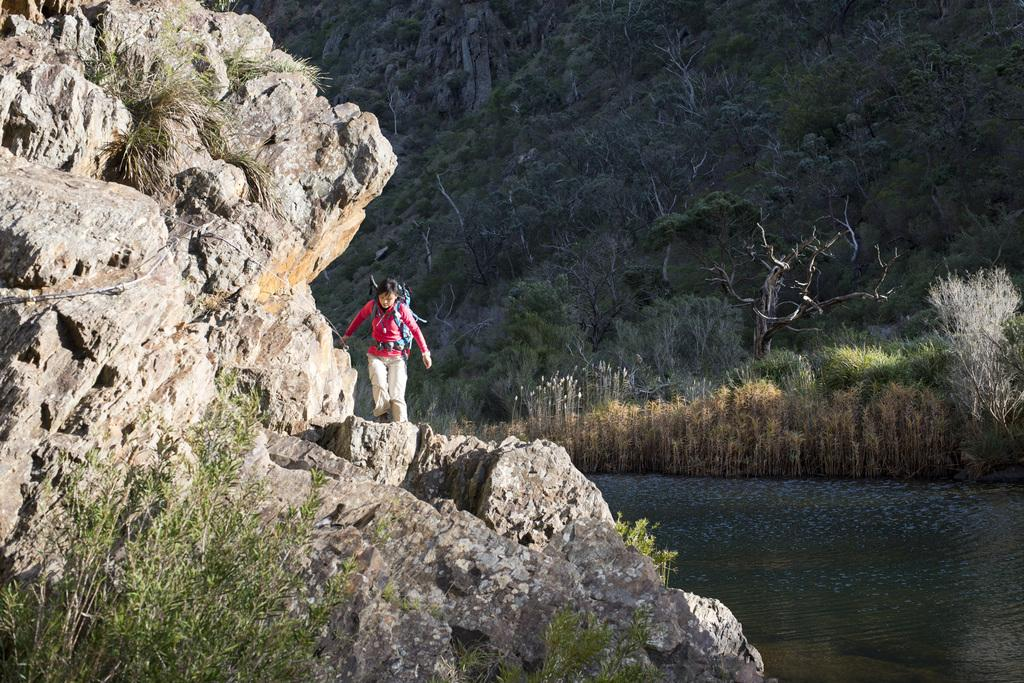What type of living organisms can be seen in the image? Plants can be seen in the image. What other objects are present in the image? There are rocks and a person carrying a bag in the image. What can be seen in the water in the image? There is no specific detail about the water in the image. What is visible in the background of the image? There are trees in the background of the image. What type of bell can be heard ringing in the image? There is no bell present in the image, and therefore no sound can be heard. 